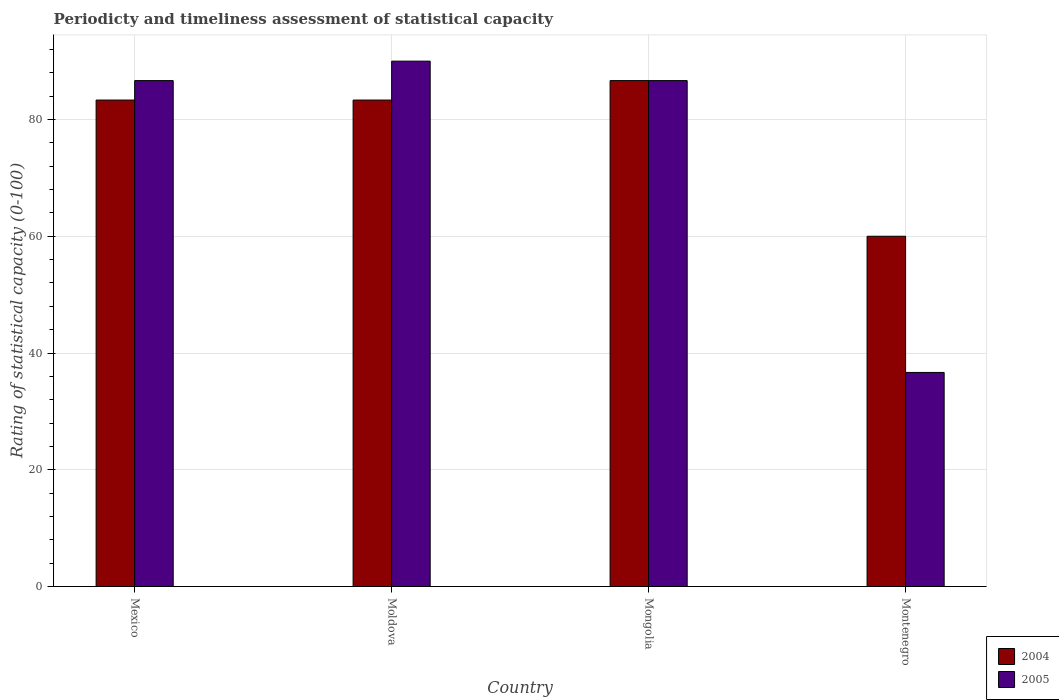Are the number of bars per tick equal to the number of legend labels?
Ensure brevity in your answer.  Yes. How many bars are there on the 2nd tick from the right?
Your answer should be compact. 2. What is the label of the 1st group of bars from the left?
Ensure brevity in your answer.  Mexico. In how many cases, is the number of bars for a given country not equal to the number of legend labels?
Your answer should be very brief. 0. What is the rating of statistical capacity in 2004 in Mongolia?
Your answer should be compact. 86.67. Across all countries, what is the maximum rating of statistical capacity in 2004?
Your answer should be very brief. 86.67. Across all countries, what is the minimum rating of statistical capacity in 2005?
Give a very brief answer. 36.67. In which country was the rating of statistical capacity in 2004 maximum?
Provide a succinct answer. Mongolia. In which country was the rating of statistical capacity in 2004 minimum?
Offer a terse response. Montenegro. What is the total rating of statistical capacity in 2004 in the graph?
Your response must be concise. 313.33. What is the difference between the rating of statistical capacity in 2004 in Mexico and that in Moldova?
Provide a succinct answer. 0. What is the difference between the rating of statistical capacity in 2005 in Montenegro and the rating of statistical capacity in 2004 in Moldova?
Offer a very short reply. -46.66. What is the average rating of statistical capacity in 2004 per country?
Keep it short and to the point. 78.33. What is the difference between the rating of statistical capacity of/in 2004 and rating of statistical capacity of/in 2005 in Mexico?
Your answer should be very brief. -3.33. What is the ratio of the rating of statistical capacity in 2005 in Moldova to that in Mongolia?
Provide a succinct answer. 1.04. Is the rating of statistical capacity in 2005 in Mexico less than that in Moldova?
Provide a short and direct response. Yes. Is the difference between the rating of statistical capacity in 2004 in Moldova and Montenegro greater than the difference between the rating of statistical capacity in 2005 in Moldova and Montenegro?
Offer a very short reply. No. What is the difference between the highest and the second highest rating of statistical capacity in 2004?
Make the answer very short. -3.33. What is the difference between the highest and the lowest rating of statistical capacity in 2004?
Keep it short and to the point. 26.67. In how many countries, is the rating of statistical capacity in 2005 greater than the average rating of statistical capacity in 2005 taken over all countries?
Give a very brief answer. 3. Is the sum of the rating of statistical capacity in 2004 in Mongolia and Montenegro greater than the maximum rating of statistical capacity in 2005 across all countries?
Your response must be concise. Yes. What does the 1st bar from the right in Moldova represents?
Your answer should be compact. 2005. How many bars are there?
Provide a short and direct response. 8. How many countries are there in the graph?
Provide a succinct answer. 4. What is the difference between two consecutive major ticks on the Y-axis?
Ensure brevity in your answer.  20. Are the values on the major ticks of Y-axis written in scientific E-notation?
Make the answer very short. No. Does the graph contain any zero values?
Offer a very short reply. No. What is the title of the graph?
Your answer should be compact. Periodicty and timeliness assessment of statistical capacity. Does "2000" appear as one of the legend labels in the graph?
Offer a very short reply. No. What is the label or title of the X-axis?
Ensure brevity in your answer.  Country. What is the label or title of the Y-axis?
Offer a terse response. Rating of statistical capacity (0-100). What is the Rating of statistical capacity (0-100) of 2004 in Mexico?
Your answer should be compact. 83.33. What is the Rating of statistical capacity (0-100) in 2005 in Mexico?
Make the answer very short. 86.67. What is the Rating of statistical capacity (0-100) of 2004 in Moldova?
Give a very brief answer. 83.33. What is the Rating of statistical capacity (0-100) in 2004 in Mongolia?
Provide a short and direct response. 86.67. What is the Rating of statistical capacity (0-100) in 2005 in Mongolia?
Your answer should be compact. 86.67. What is the Rating of statistical capacity (0-100) of 2005 in Montenegro?
Keep it short and to the point. 36.67. Across all countries, what is the maximum Rating of statistical capacity (0-100) in 2004?
Your answer should be very brief. 86.67. Across all countries, what is the minimum Rating of statistical capacity (0-100) of 2004?
Make the answer very short. 60. Across all countries, what is the minimum Rating of statistical capacity (0-100) in 2005?
Ensure brevity in your answer.  36.67. What is the total Rating of statistical capacity (0-100) in 2004 in the graph?
Keep it short and to the point. 313.33. What is the total Rating of statistical capacity (0-100) of 2005 in the graph?
Ensure brevity in your answer.  300. What is the difference between the Rating of statistical capacity (0-100) of 2004 in Mexico and that in Moldova?
Make the answer very short. 0. What is the difference between the Rating of statistical capacity (0-100) in 2004 in Mexico and that in Mongolia?
Give a very brief answer. -3.33. What is the difference between the Rating of statistical capacity (0-100) of 2005 in Mexico and that in Mongolia?
Offer a terse response. 0. What is the difference between the Rating of statistical capacity (0-100) of 2004 in Mexico and that in Montenegro?
Provide a short and direct response. 23.33. What is the difference between the Rating of statistical capacity (0-100) in 2005 in Mexico and that in Montenegro?
Provide a short and direct response. 50. What is the difference between the Rating of statistical capacity (0-100) of 2004 in Moldova and that in Mongolia?
Provide a succinct answer. -3.33. What is the difference between the Rating of statistical capacity (0-100) of 2005 in Moldova and that in Mongolia?
Keep it short and to the point. 3.33. What is the difference between the Rating of statistical capacity (0-100) in 2004 in Moldova and that in Montenegro?
Provide a succinct answer. 23.33. What is the difference between the Rating of statistical capacity (0-100) of 2005 in Moldova and that in Montenegro?
Offer a very short reply. 53.33. What is the difference between the Rating of statistical capacity (0-100) of 2004 in Mongolia and that in Montenegro?
Keep it short and to the point. 26.67. What is the difference between the Rating of statistical capacity (0-100) of 2005 in Mongolia and that in Montenegro?
Provide a short and direct response. 50. What is the difference between the Rating of statistical capacity (0-100) in 2004 in Mexico and the Rating of statistical capacity (0-100) in 2005 in Moldova?
Your response must be concise. -6.67. What is the difference between the Rating of statistical capacity (0-100) in 2004 in Mexico and the Rating of statistical capacity (0-100) in 2005 in Montenegro?
Make the answer very short. 46.66. What is the difference between the Rating of statistical capacity (0-100) in 2004 in Moldova and the Rating of statistical capacity (0-100) in 2005 in Montenegro?
Your response must be concise. 46.66. What is the difference between the Rating of statistical capacity (0-100) of 2004 in Mongolia and the Rating of statistical capacity (0-100) of 2005 in Montenegro?
Make the answer very short. 50. What is the average Rating of statistical capacity (0-100) of 2004 per country?
Your response must be concise. 78.33. What is the average Rating of statistical capacity (0-100) of 2005 per country?
Give a very brief answer. 75. What is the difference between the Rating of statistical capacity (0-100) of 2004 and Rating of statistical capacity (0-100) of 2005 in Moldova?
Keep it short and to the point. -6.67. What is the difference between the Rating of statistical capacity (0-100) in 2004 and Rating of statistical capacity (0-100) in 2005 in Montenegro?
Offer a terse response. 23.33. What is the ratio of the Rating of statistical capacity (0-100) in 2004 in Mexico to that in Moldova?
Offer a terse response. 1. What is the ratio of the Rating of statistical capacity (0-100) in 2005 in Mexico to that in Moldova?
Make the answer very short. 0.96. What is the ratio of the Rating of statistical capacity (0-100) in 2004 in Mexico to that in Mongolia?
Give a very brief answer. 0.96. What is the ratio of the Rating of statistical capacity (0-100) in 2004 in Mexico to that in Montenegro?
Provide a short and direct response. 1.39. What is the ratio of the Rating of statistical capacity (0-100) in 2005 in Mexico to that in Montenegro?
Provide a succinct answer. 2.36. What is the ratio of the Rating of statistical capacity (0-100) in 2004 in Moldova to that in Mongolia?
Make the answer very short. 0.96. What is the ratio of the Rating of statistical capacity (0-100) in 2004 in Moldova to that in Montenegro?
Your answer should be very brief. 1.39. What is the ratio of the Rating of statistical capacity (0-100) in 2005 in Moldova to that in Montenegro?
Make the answer very short. 2.45. What is the ratio of the Rating of statistical capacity (0-100) of 2004 in Mongolia to that in Montenegro?
Your answer should be very brief. 1.44. What is the ratio of the Rating of statistical capacity (0-100) in 2005 in Mongolia to that in Montenegro?
Provide a short and direct response. 2.36. What is the difference between the highest and the lowest Rating of statistical capacity (0-100) in 2004?
Keep it short and to the point. 26.67. What is the difference between the highest and the lowest Rating of statistical capacity (0-100) of 2005?
Make the answer very short. 53.33. 